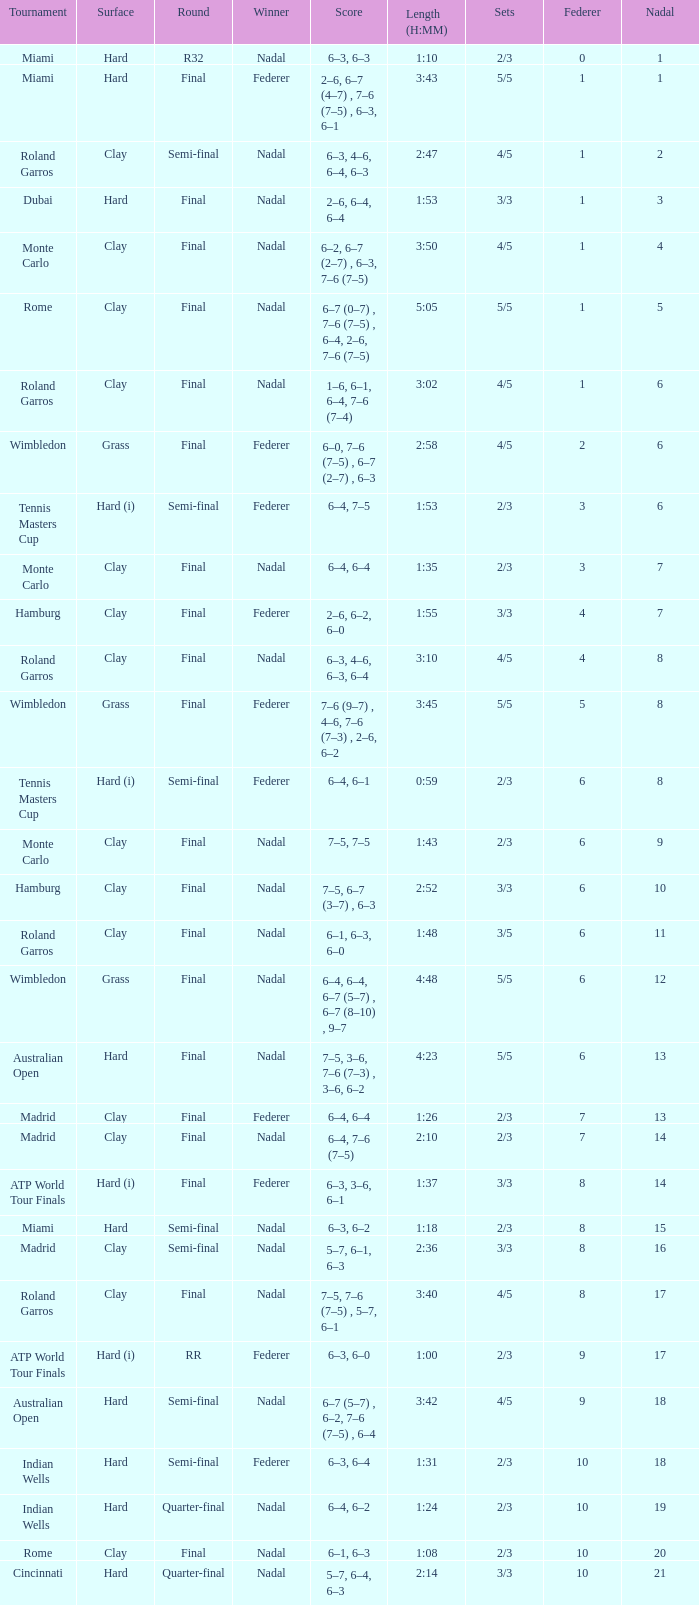Can you parse all the data within this table? {'header': ['Tournament', 'Surface', 'Round', 'Winner', 'Score', 'Length (H:MM)', 'Sets', 'Federer', 'Nadal'], 'rows': [['Miami', 'Hard', 'R32', 'Nadal', '6–3, 6–3', '1:10', '2/3', '0', '1'], ['Miami', 'Hard', 'Final', 'Federer', '2–6, 6–7 (4–7) , 7–6 (7–5) , 6–3, 6–1', '3:43', '5/5', '1', '1'], ['Roland Garros', 'Clay', 'Semi-final', 'Nadal', '6–3, 4–6, 6–4, 6–3', '2:47', '4/5', '1', '2'], ['Dubai', 'Hard', 'Final', 'Nadal', '2–6, 6–4, 6–4', '1:53', '3/3', '1', '3'], ['Monte Carlo', 'Clay', 'Final', 'Nadal', '6–2, 6–7 (2–7) , 6–3, 7–6 (7–5)', '3:50', '4/5', '1', '4'], ['Rome', 'Clay', 'Final', 'Nadal', '6–7 (0–7) , 7–6 (7–5) , 6–4, 2–6, 7–6 (7–5)', '5:05', '5/5', '1', '5'], ['Roland Garros', 'Clay', 'Final', 'Nadal', '1–6, 6–1, 6–4, 7–6 (7–4)', '3:02', '4/5', '1', '6'], ['Wimbledon', 'Grass', 'Final', 'Federer', '6–0, 7–6 (7–5) , 6–7 (2–7) , 6–3', '2:58', '4/5', '2', '6'], ['Tennis Masters Cup', 'Hard (i)', 'Semi-final', 'Federer', '6–4, 7–5', '1:53', '2/3', '3', '6'], ['Monte Carlo', 'Clay', 'Final', 'Nadal', '6–4, 6–4', '1:35', '2/3', '3', '7'], ['Hamburg', 'Clay', 'Final', 'Federer', '2–6, 6–2, 6–0', '1:55', '3/3', '4', '7'], ['Roland Garros', 'Clay', 'Final', 'Nadal', '6–3, 4–6, 6–3, 6–4', '3:10', '4/5', '4', '8'], ['Wimbledon', 'Grass', 'Final', 'Federer', '7–6 (9–7) , 4–6, 7–6 (7–3) , 2–6, 6–2', '3:45', '5/5', '5', '8'], ['Tennis Masters Cup', 'Hard (i)', 'Semi-final', 'Federer', '6–4, 6–1', '0:59', '2/3', '6', '8'], ['Monte Carlo', 'Clay', 'Final', 'Nadal', '7–5, 7–5', '1:43', '2/3', '6', '9'], ['Hamburg', 'Clay', 'Final', 'Nadal', '7–5, 6–7 (3–7) , 6–3', '2:52', '3/3', '6', '10'], ['Roland Garros', 'Clay', 'Final', 'Nadal', '6–1, 6–3, 6–0', '1:48', '3/5', '6', '11'], ['Wimbledon', 'Grass', 'Final', 'Nadal', '6–4, 6–4, 6–7 (5–7) , 6–7 (8–10) , 9–7', '4:48', '5/5', '6', '12'], ['Australian Open', 'Hard', 'Final', 'Nadal', '7–5, 3–6, 7–6 (7–3) , 3–6, 6–2', '4:23', '5/5', '6', '13'], ['Madrid', 'Clay', 'Final', 'Federer', '6–4, 6–4', '1:26', '2/3', '7', '13'], ['Madrid', 'Clay', 'Final', 'Nadal', '6–4, 7–6 (7–5)', '2:10', '2/3', '7', '14'], ['ATP World Tour Finals', 'Hard (i)', 'Final', 'Federer', '6–3, 3–6, 6–1', '1:37', '3/3', '8', '14'], ['Miami', 'Hard', 'Semi-final', 'Nadal', '6–3, 6–2', '1:18', '2/3', '8', '15'], ['Madrid', 'Clay', 'Semi-final', 'Nadal', '5–7, 6–1, 6–3', '2:36', '3/3', '8', '16'], ['Roland Garros', 'Clay', 'Final', 'Nadal', '7–5, 7–6 (7–5) , 5–7, 6–1', '3:40', '4/5', '8', '17'], ['ATP World Tour Finals', 'Hard (i)', 'RR', 'Federer', '6–3, 6–0', '1:00', '2/3', '9', '17'], ['Australian Open', 'Hard', 'Semi-final', 'Nadal', '6–7 (5–7) , 6–2, 7–6 (7–5) , 6–4', '3:42', '4/5', '9', '18'], ['Indian Wells', 'Hard', 'Semi-final', 'Federer', '6–3, 6–4', '1:31', '2/3', '10', '18'], ['Indian Wells', 'Hard', 'Quarter-final', 'Nadal', '6–4, 6–2', '1:24', '2/3', '10', '19'], ['Rome', 'Clay', 'Final', 'Nadal', '6–1, 6–3', '1:08', '2/3', '10', '20'], ['Cincinnati', 'Hard', 'Quarter-final', 'Nadal', '5–7, 6–4, 6–3', '2:14', '3/3', '10', '21']]} What was the outcome for nadal in the final round in miami? 1.0. 